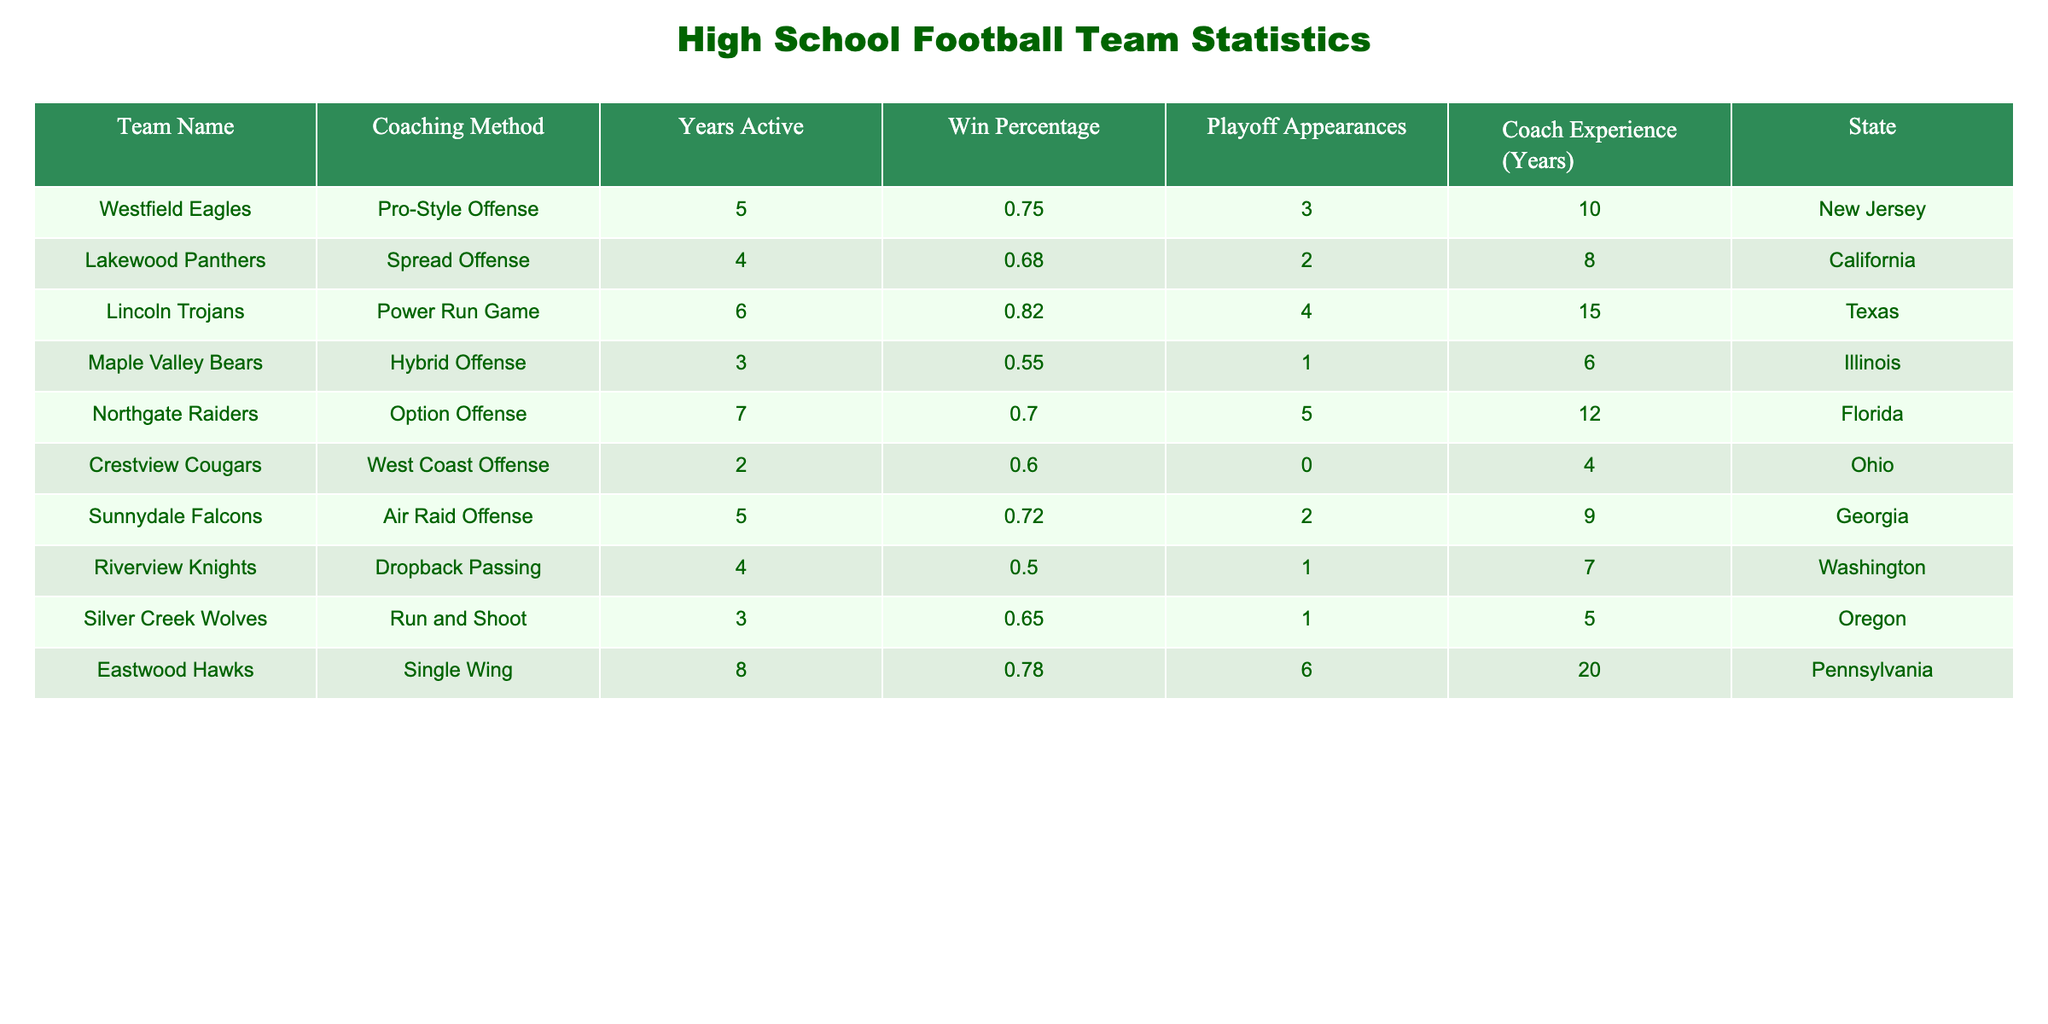What is the win percentage of the Lincoln Trojans? The win percentage is listed directly in the table under the corresponding row for the Lincoln Trojans, which shows a win percentage of 0.82.
Answer: 0.82 Which coaching method has the lowest win percentage? By comparing the win percentages of all teams, the Maple Valley Bears, with a win percentage of 0.55, has the lowest value among the entries.
Answer: Hybrid Offense How many playoff appearances did the Northgate Raiders have? The number of playoff appearances is directly stated in the Northgate Raiders row under the "Playoff Appearances" column, which shows a total of 5 appearances.
Answer: 5 What is the average coach experience of the teams using a spread offense? The teams using a spread offense is identified as the Lakewood Panthers and to find their average experience, we take the coach experience of 8 years (for Lakewood Panthers, which is the only team with this coaching method). Since there's only one team, the average experience is 8 years.
Answer: 8 Is it true that teams from Texas have a higher win percentage than teams from California? The Lincoln Trojans from Texas have a win percentage of 0.82, while the Lakewood Panthers from California have a win percentage of 0.68. Thus, this statement is true, as 0.82 is greater than 0.68.
Answer: True What is the total number of playoff appearances from all teams that use a single wing coaching method? Examining the table, there is only one team using the single wing coaching method, the Eastwood Hawks, which has 6 playoff appearances. Therefore, the total is simply 6.
Answer: 6 Does the Crestview Cougars have more coach experience than the Sunnydale Falcons? The table shows the Crestview Cougars with 4 years of coaching experience, while the Sunnydale Falcons have 9 years. Since 4 is not greater than 9, the answer is no.
Answer: No Which state has the highest win percentage among its football teams? To find the highest win percentage by state, we look at the win percentages listed for all teams by their respective states. The highest is for the Lincoln Trojans in Texas with a win percentage of 0.82.
Answer: Texas What is the difference between the highest and lowest win percentages in the table? The highest win percentage is 0.82 (Lincoln Trojans) and the lowest is 0.55 (Maple Valley Bears). Calculating the difference: 0.82 - 0.55 = 0.27.
Answer: 0.27 